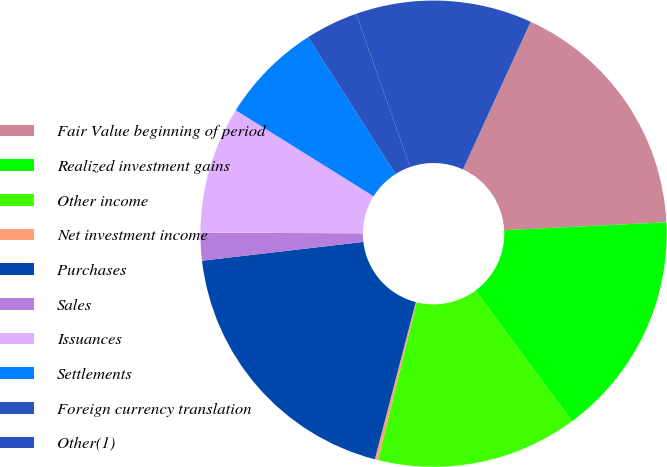Convert chart. <chart><loc_0><loc_0><loc_500><loc_500><pie_chart><fcel>Fair Value beginning of period<fcel>Realized investment gains<fcel>Other income<fcel>Net investment income<fcel>Purchases<fcel>Sales<fcel>Issuances<fcel>Settlements<fcel>Foreign currency translation<fcel>Other(1)<nl><fcel>17.38%<fcel>15.66%<fcel>13.95%<fcel>0.22%<fcel>19.1%<fcel>1.93%<fcel>8.8%<fcel>7.08%<fcel>3.65%<fcel>12.23%<nl></chart> 